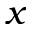<formula> <loc_0><loc_0><loc_500><loc_500>x</formula> 